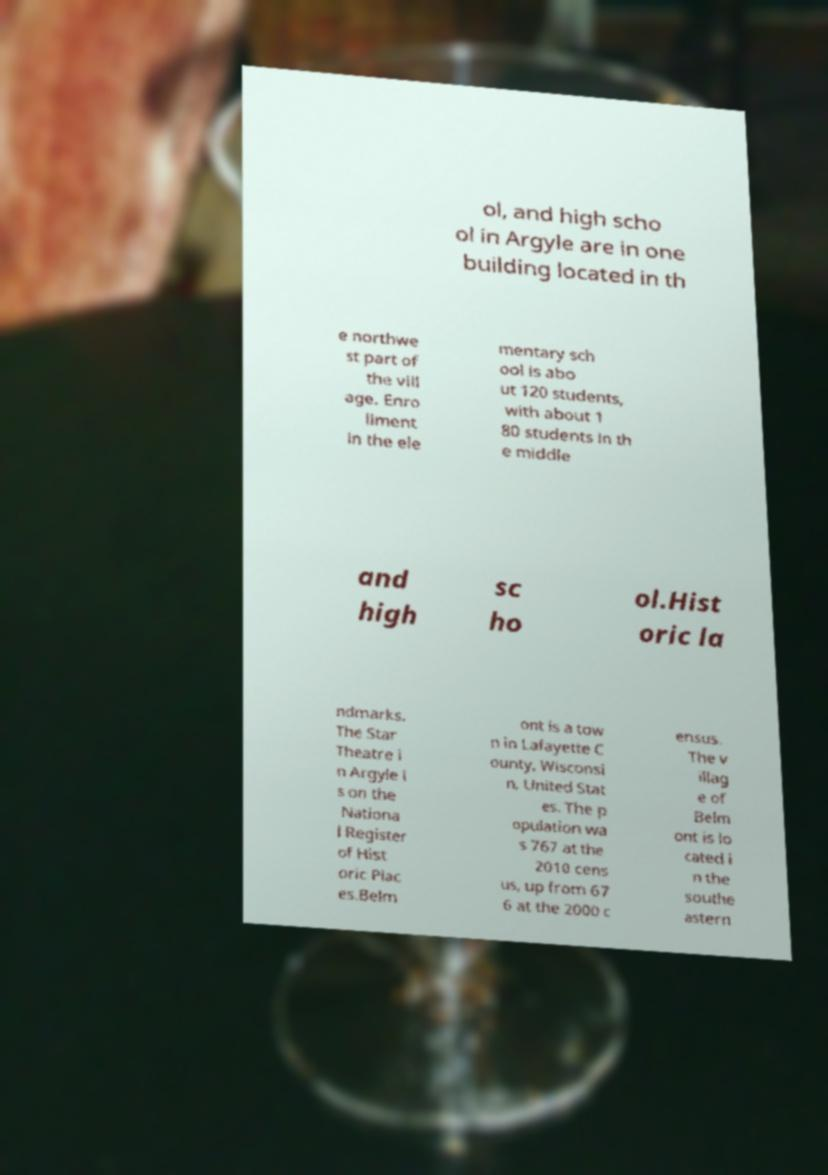There's text embedded in this image that I need extracted. Can you transcribe it verbatim? ol, and high scho ol in Argyle are in one building located in th e northwe st part of the vill age. Enro llment in the ele mentary sch ool is abo ut 120 students, with about 1 80 students in th e middle and high sc ho ol.Hist oric la ndmarks. The Star Theatre i n Argyle i s on the Nationa l Register of Hist oric Plac es.Belm ont is a tow n in Lafayette C ounty, Wisconsi n, United Stat es. The p opulation wa s 767 at the 2010 cens us, up from 67 6 at the 2000 c ensus. The v illag e of Belm ont is lo cated i n the southe astern 